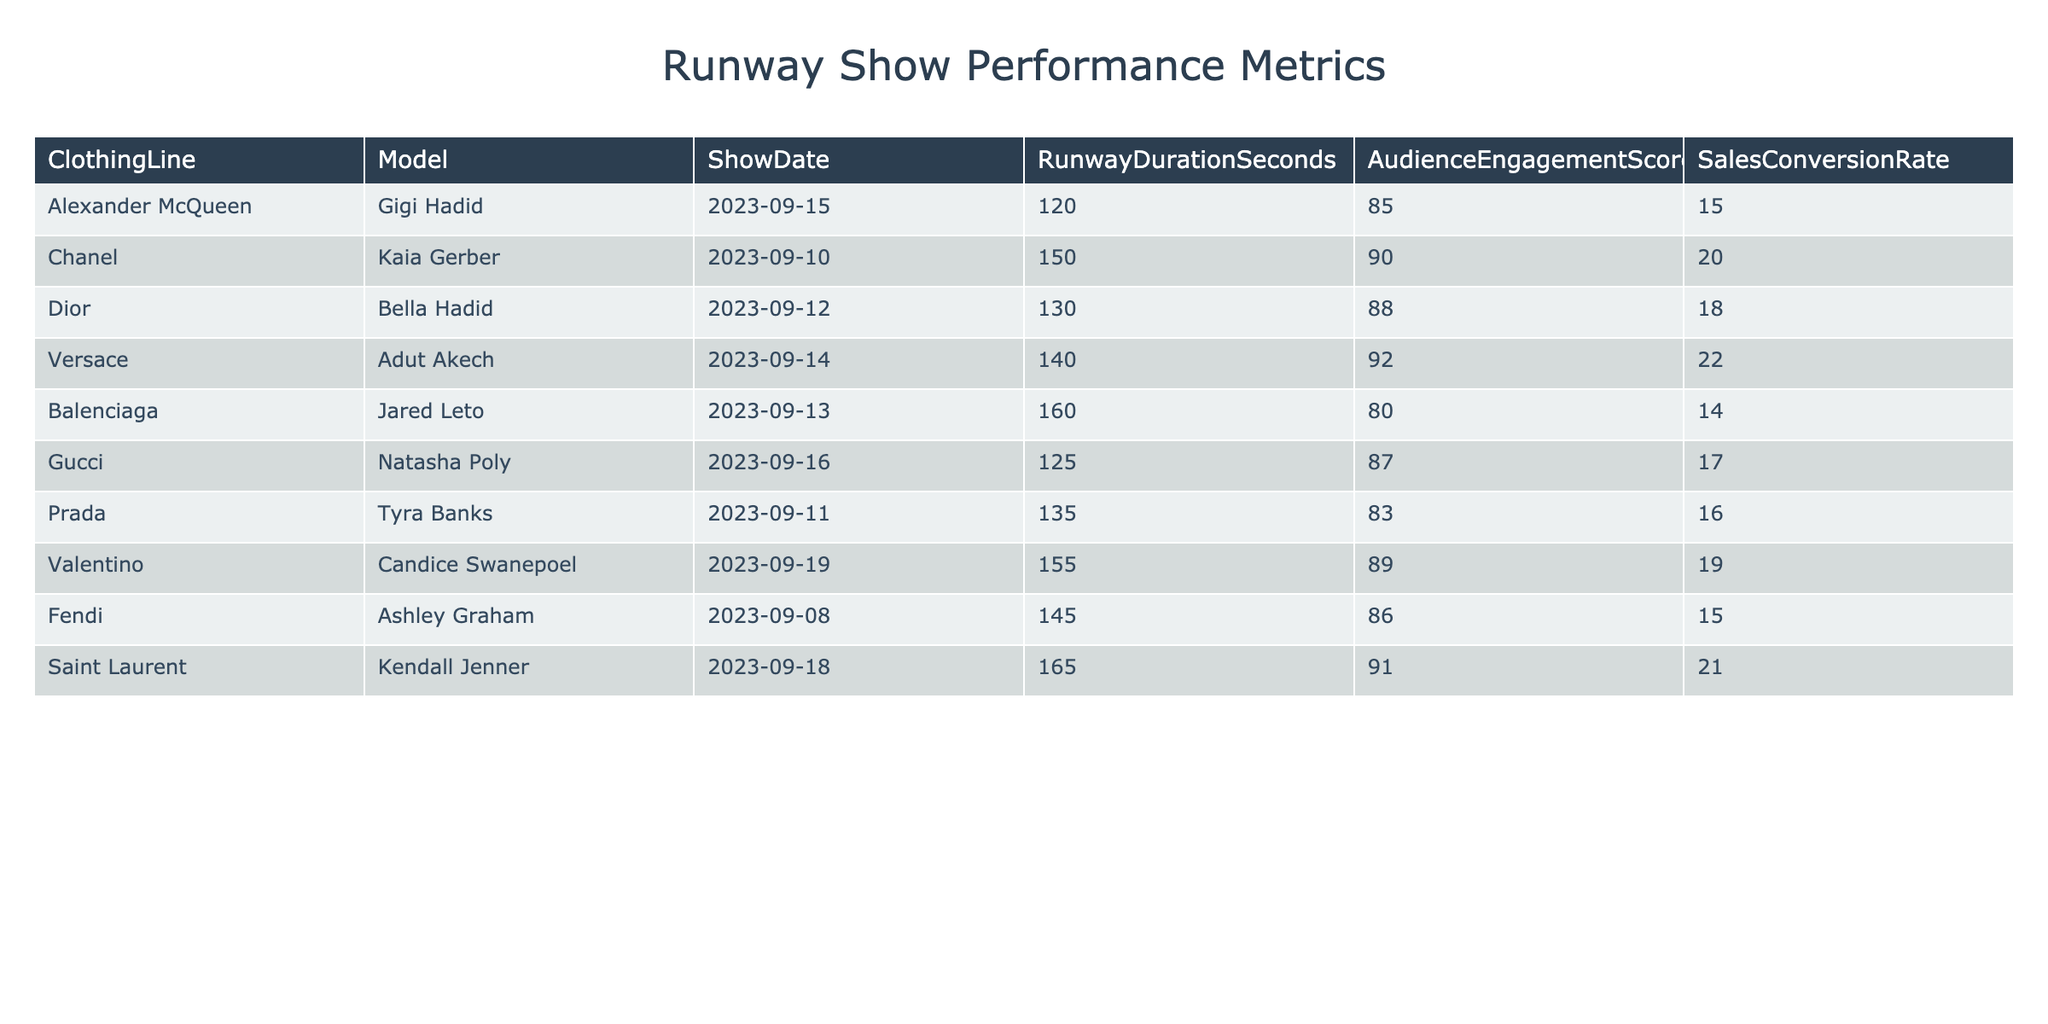What is the audience engagement score for the Versace show? The audience engagement score for the Versace show is listed in the table, which shows the corresponding value next to the clothing line and model. For Versace and the model Adut Akech, the engagement score is 92.
Answer: 92 Which model had the highest sales conversion rate? By checking the sales conversion rates in the table, we see that Saint Laurent, modeled by Kendall Jenner, has the highest rate of 21.
Answer: 21 What is the average runway duration (in seconds) for the shows? To find the average runway duration, we sum all the durations of the shows: (120 + 150 + 130 + 140 + 160 + 125 + 135 + 155 + 145 + 165) = 1,500 seconds. There are 10 shows, so we divide 1,500 by 10, which equals 150 seconds.
Answer: 150 Is the sales conversion rate for Balenciaga higher than for Dior? The sales conversion rate for Balenciaga is 14, while for Dior it is 18. Comparing these, we see that 14 is not higher than 18.
Answer: No How does the average audience engagement score compare for models with sales conversion rates above 18? First, we need to identify models with sales conversion rates above 18, which are Kaia Gerber (20), Adut Akech (22), Valentino (19), and Kendall Jenner (21). Their respective engagement scores are 90, 92, 89, and 91. We sum these scores: (90 + 92 + 89 + 91) = 362. There are 4 models, so the average is 362 / 4 = 90.5.
Answer: 90.5 Which clothing line had the longest runway duration and what is that duration? To determine which clothing line had the longest runway duration, we scan the durations listed. The maximum value appears with Balenciaga having 160 seconds, which is the longest among the entries.
Answer: 160 Did any model have an engagement score lower than 85? Looking at the engagement scores presented, we see that the lowest score is for Balenciaga, which is 80. Therefore, yes, there is a model with an engagement score lower than 85.
Answer: Yes What is the total sales conversion rate across all the shows? We sum the sales conversion rates listed: (15 + 20 + 18 + 22 + 14 + 17 + 16 + 19 + 15 + 21) =  177. This total represents the combined sales conversion rate for all shows.
Answer: 177 